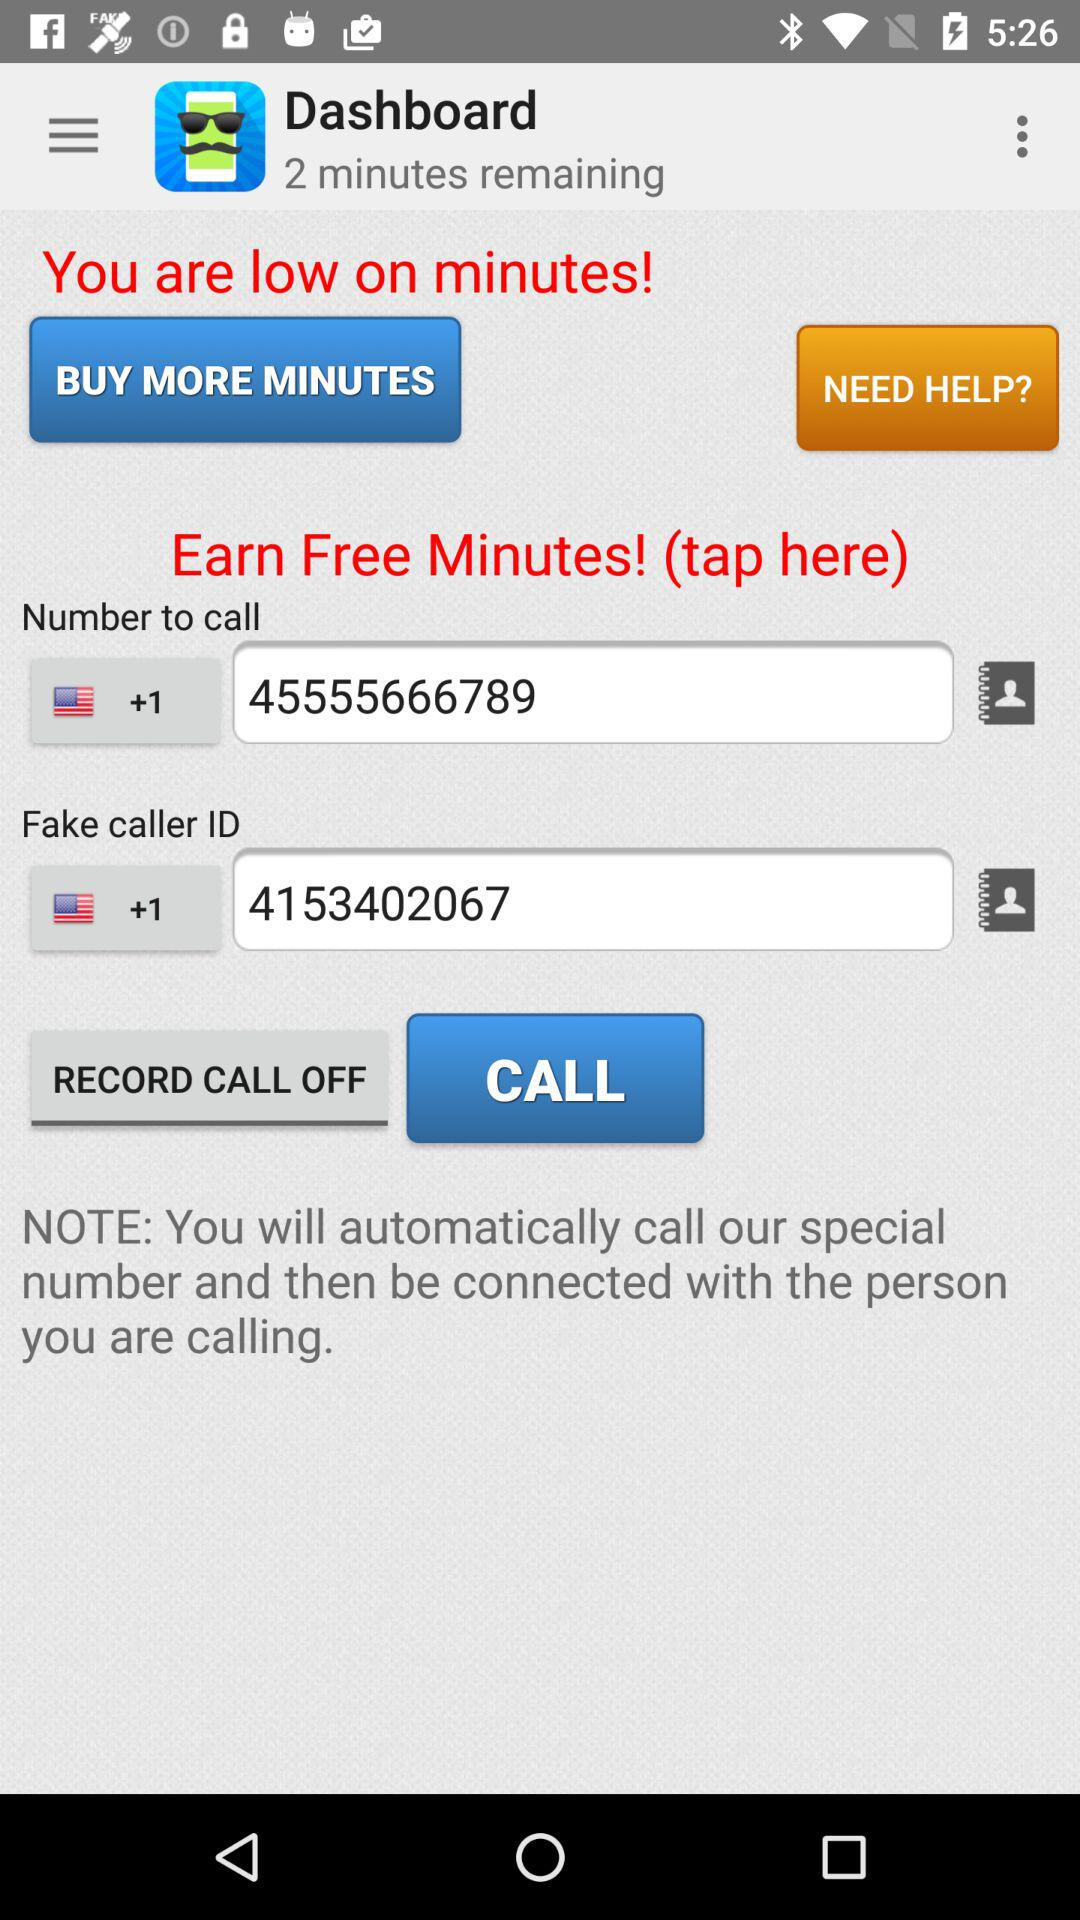What is the fake caller ID? The fake caller ID is +1 4153402067. 